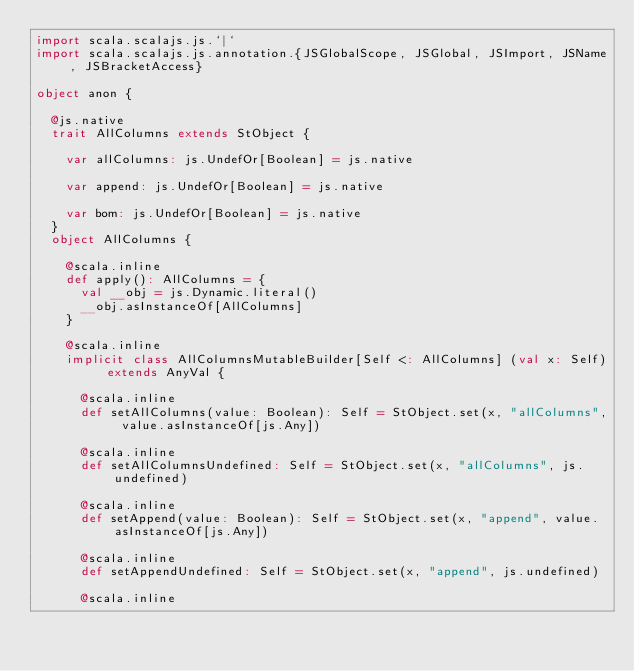Convert code to text. <code><loc_0><loc_0><loc_500><loc_500><_Scala_>import scala.scalajs.js.`|`
import scala.scalajs.js.annotation.{JSGlobalScope, JSGlobal, JSImport, JSName, JSBracketAccess}

object anon {
  
  @js.native
  trait AllColumns extends StObject {
    
    var allColumns: js.UndefOr[Boolean] = js.native
    
    var append: js.UndefOr[Boolean] = js.native
    
    var bom: js.UndefOr[Boolean] = js.native
  }
  object AllColumns {
    
    @scala.inline
    def apply(): AllColumns = {
      val __obj = js.Dynamic.literal()
      __obj.asInstanceOf[AllColumns]
    }
    
    @scala.inline
    implicit class AllColumnsMutableBuilder[Self <: AllColumns] (val x: Self) extends AnyVal {
      
      @scala.inline
      def setAllColumns(value: Boolean): Self = StObject.set(x, "allColumns", value.asInstanceOf[js.Any])
      
      @scala.inline
      def setAllColumnsUndefined: Self = StObject.set(x, "allColumns", js.undefined)
      
      @scala.inline
      def setAppend(value: Boolean): Self = StObject.set(x, "append", value.asInstanceOf[js.Any])
      
      @scala.inline
      def setAppendUndefined: Self = StObject.set(x, "append", js.undefined)
      
      @scala.inline</code> 